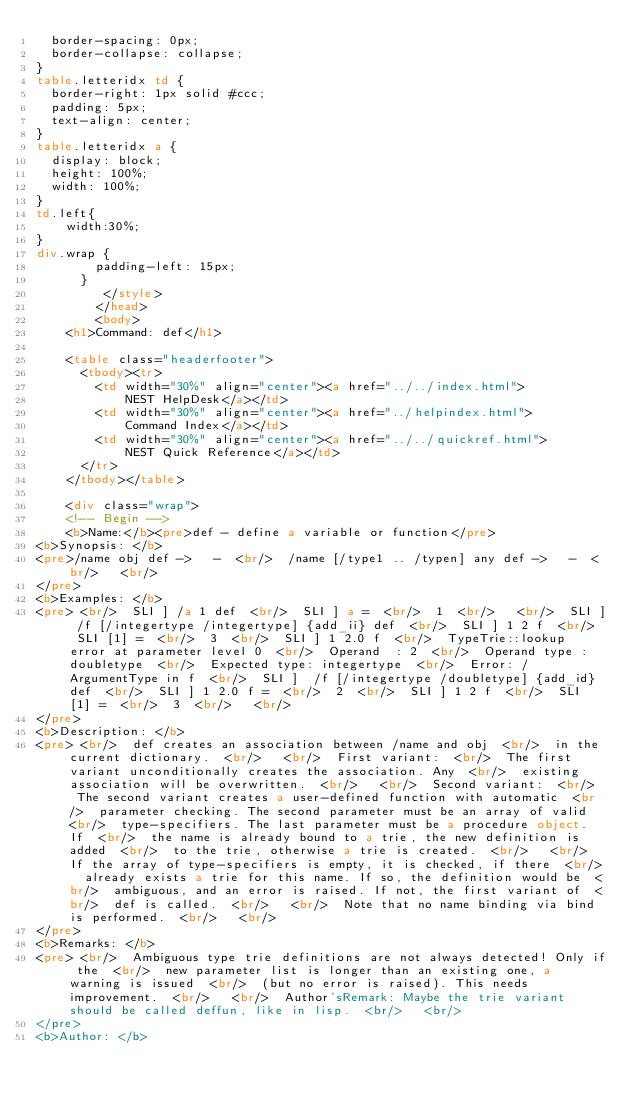<code> <loc_0><loc_0><loc_500><loc_500><_HTML_>  border-spacing: 0px;
  border-collapse: collapse;
}
table.letteridx td {
  border-right: 1px solid #ccc;
  padding: 5px;
  text-align: center;
}
table.letteridx a {
  display: block;
  height: 100%;
  width: 100%;
}
td.left{
    width:30%;
}
div.wrap {
        padding-left: 15px;
      }
         </style>
        </head>
        <body>
    <h1>Command: def</h1>

    <table class="headerfooter">
      <tbody><tr>
        <td width="30%" align="center"><a href="../../index.html">
            NEST HelpDesk</a></td>
        <td width="30%" align="center"><a href="../helpindex.html">
            Command Index</a></td>
        <td width="30%" align="center"><a href="../../quickref.html">
            NEST Quick Reference</a></td>
      </tr>
    </tbody></table>

    <div class="wrap">
    <!-- Begin -->
    <b>Name:</b><pre>def - define a variable or function</pre>
<b>Synopsis: </b>
<pre>/name obj def ->	-  <br/>  /name [/type1 .. /typen] any def ->	-  <br/>   <br/>  
</pre>
<b>Examples: </b>
<pre> <br/>  SLI ] /a 1 def  <br/>  SLI ] a =  <br/>  1  <br/>   <br/>  SLI ] /f [/integertype /integertype] {add_ii} def  <br/>  SLI ] 1 2 f  <br/>  SLI [1] =  <br/>  3  <br/>  SLI ] 1 2.0 f  <br/>  TypeTrie::lookup error at parameter level 0  <br/>  Operand	 : 2  <br/>  Operand type : doubletype  <br/>  Expected type: integertype  <br/>  Error: /ArgumentType in f  <br/>  SLI ]  /f [/integertype /doubletype] {add_id} def  <br/>  SLI ] 1 2.0 f =  <br/>  2  <br/>  SLI ] 1 2 f  <br/>  SLI [1] =  <br/>  3  <br/>   <br/>  
</pre>
<b>Description: </b>
<pre> <br/>  def creates an association between /name and obj  <br/>  in the current dictionary.  <br/>   <br/>  First variant:  <br/>  The first variant unconditionally creates the association. Any  <br/>  existing association will be overwritten.  <br/>   <br/>  Second variant:  <br/>  The second variant creates a user-defined function with automatic  <br/>  parameter checking. The second parameter must be an array of valid  <br/>  type-specifiers. The last parameter must be a procedure object. If  <br/>  the name is already bound to a trie, the new definition is added  <br/>  to the trie, otherwise a trie is created.  <br/>   <br/>  If the array of type-specifiers is empty, it is checked, if there  <br/>  already exists a trie for this name. If so, the definition would be  <br/>  ambiguous, and an error is raised. If not, the first variant of  <br/>  def is called.  <br/>   <br/>  Note that no name binding via bind is performed.  <br/>   <br/>  
</pre>
<b>Remarks: </b>
<pre> <br/>  Ambiguous type trie definitions are not always detected! Only if the  <br/>  new parameter list is longer than an existing one, a warning is issued  <br/>  (but no error is raised). This needs improvement.  <br/>   <br/>  Author'sRemark: Maybe the trie variant should be called deffun, like in lisp.  <br/>   <br/>  
</pre>
<b>Author: </b></code> 